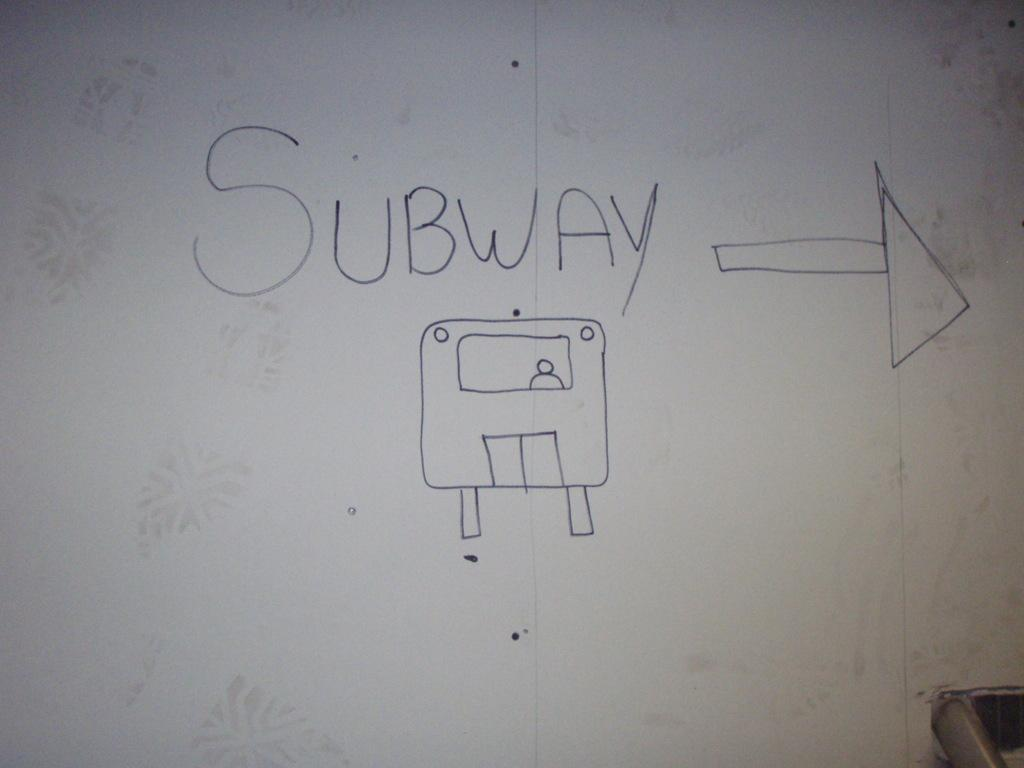Provide a one-sentence caption for the provided image. A white board with the word Subway written on it. 